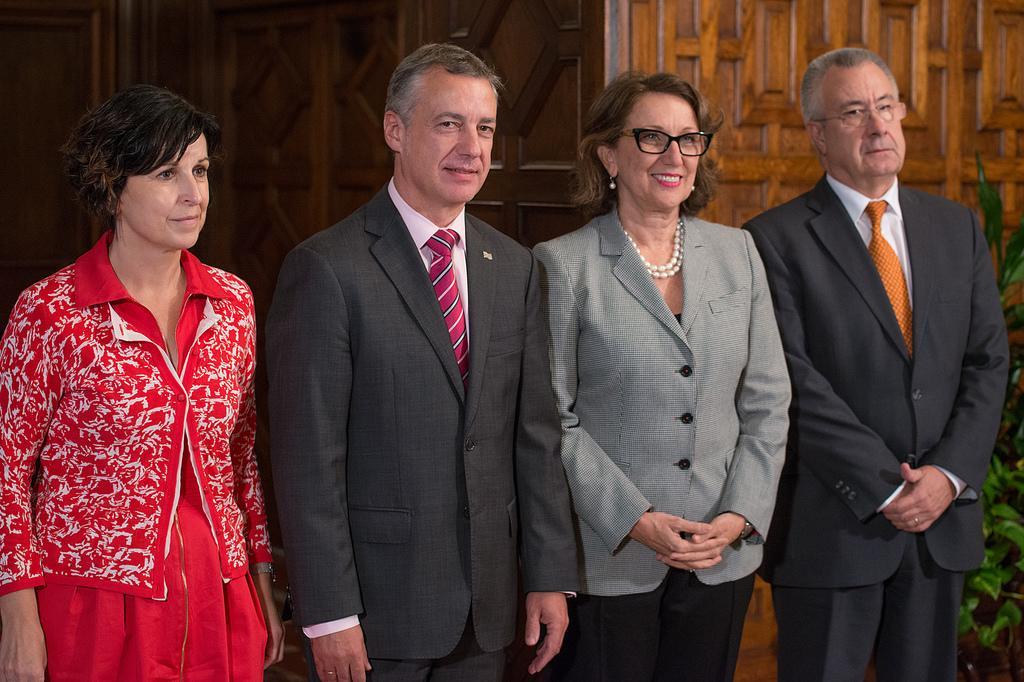Describe this image in one or two sentences. In this image, I can see four persons standing and smiling. In the background, there is a wooden wall. On the right corner of the image, I can see a plant. 